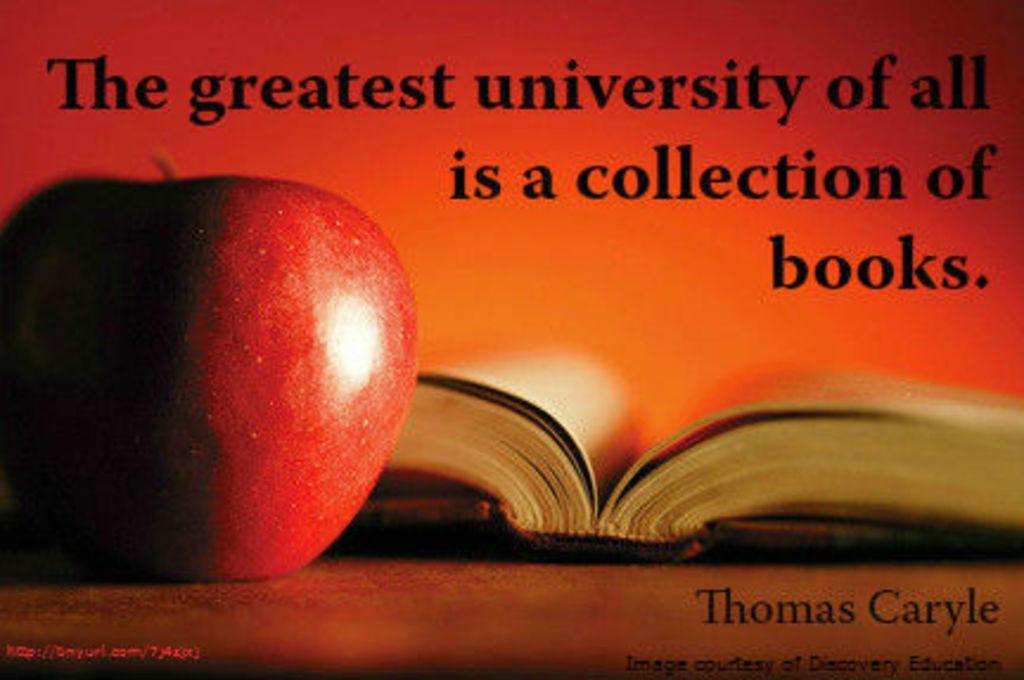How would you summarize this image in a sentence or two? In this image there is an apple and a book on the table. There is some text on top and bottom of the image. 